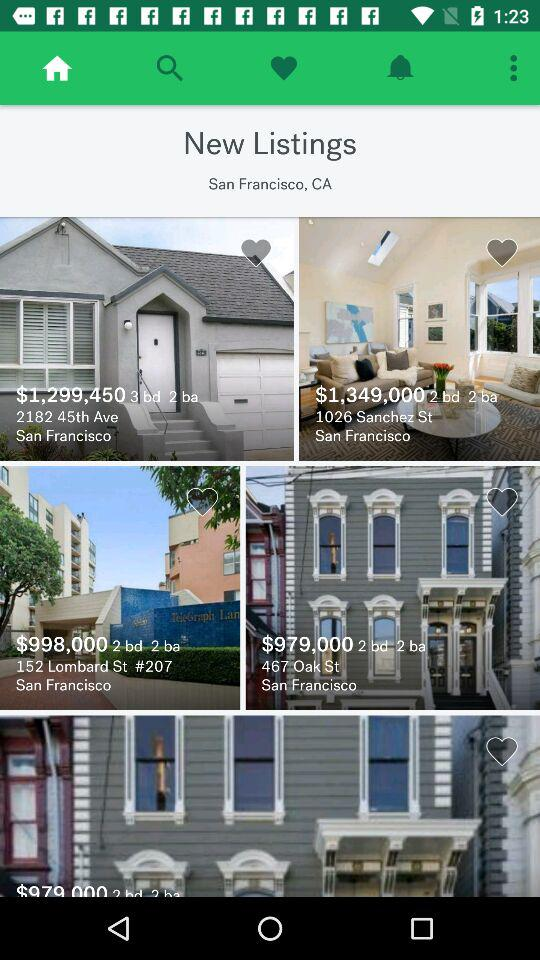What is the price of the house whose address is 2182 45th Ave? The price of the house is $1,299,450. 